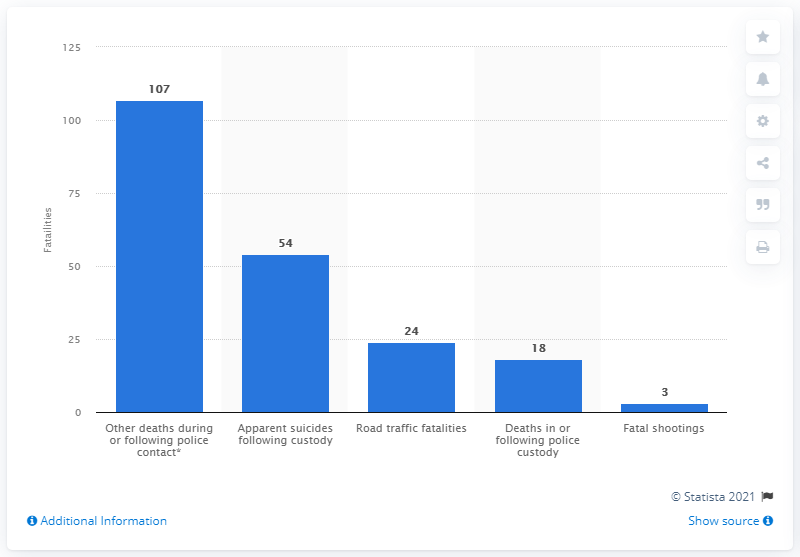Indicate a few pertinent items in this graphic. There were 107 police-related deaths in England and Wales during the financial year 2019/20. 